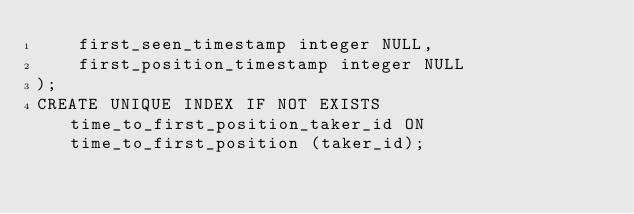<code> <loc_0><loc_0><loc_500><loc_500><_SQL_>    first_seen_timestamp integer NULL,
    first_position_timestamp integer NULL
);
CREATE UNIQUE INDEX IF NOT EXISTS time_to_first_position_taker_id ON time_to_first_position (taker_id);
</code> 